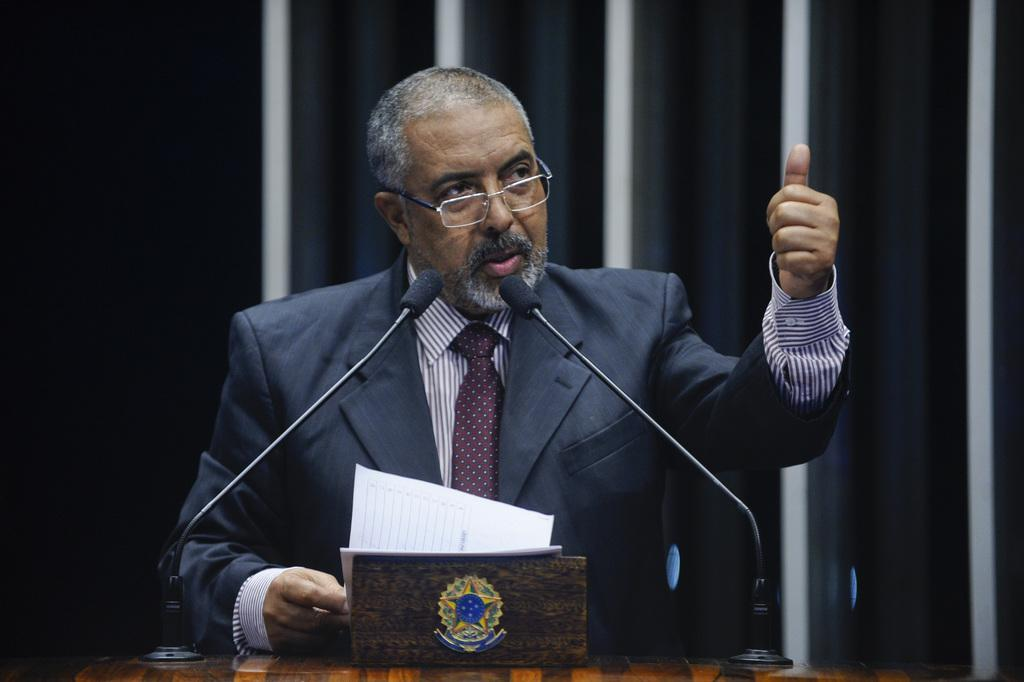What is the main subject of the image? There is a person in the image. What is the person wearing? The person is wearing a black suit. What is the person doing in the image? The person is standing. What objects are in front of the person? There are two microphones and papers in front of the person. What is the color scheme of the background in the image? The background of the image is in black and white color. What is the person's brother doing in the image? There is no mention of a brother in the image, so we cannot answer that question. What type of judge is present in the image? There is no judge present in the image; it features a person standing with microphones and papers in front of them. 